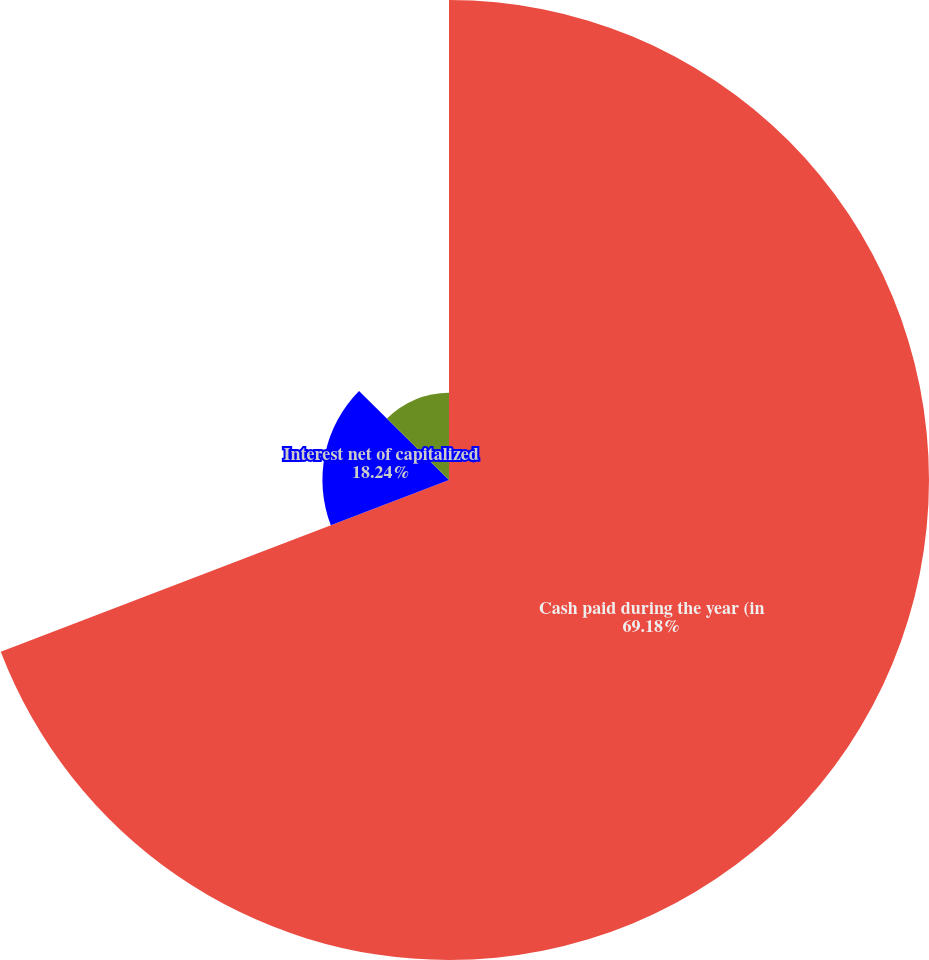Convert chart to OTSL. <chart><loc_0><loc_0><loc_500><loc_500><pie_chart><fcel>Cash paid during the year (in<fcel>Interest net of capitalized<fcel>Income taxes<nl><fcel>69.17%<fcel>18.24%<fcel>12.58%<nl></chart> 